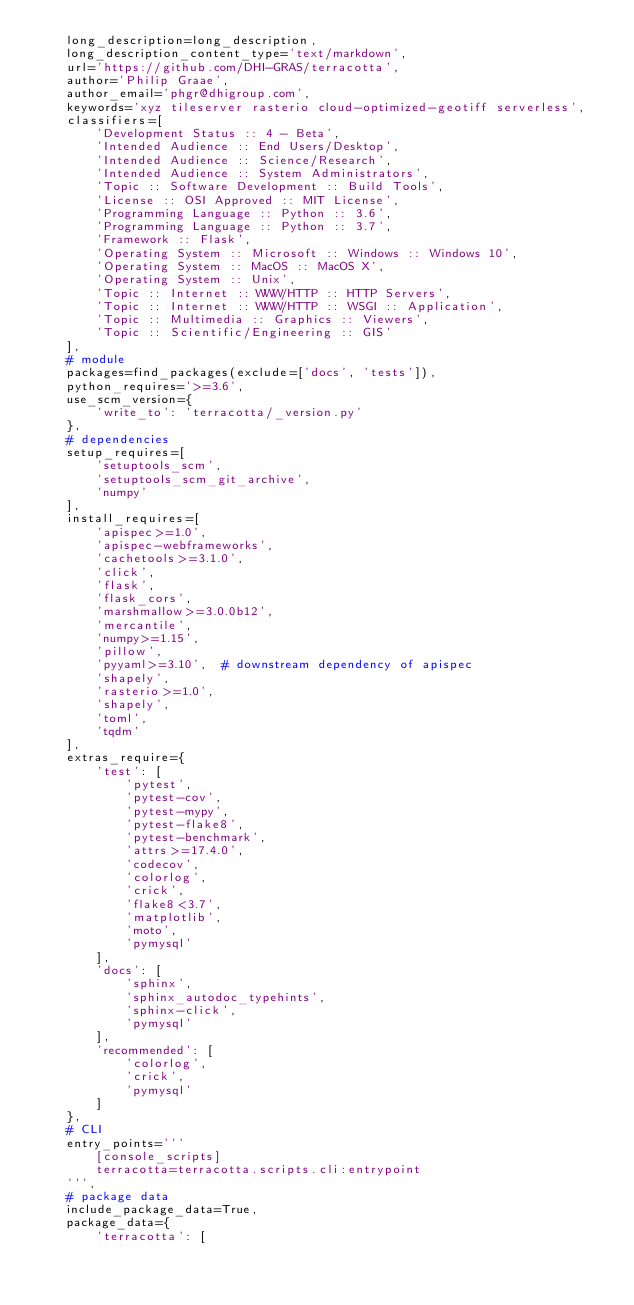<code> <loc_0><loc_0><loc_500><loc_500><_Python_>    long_description=long_description,
    long_description_content_type='text/markdown',
    url='https://github.com/DHI-GRAS/terracotta',
    author='Philip Graae',
    author_email='phgr@dhigroup.com',
    keywords='xyz tileserver rasterio cloud-optimized-geotiff serverless',
    classifiers=[
        'Development Status :: 4 - Beta',
        'Intended Audience :: End Users/Desktop',
        'Intended Audience :: Science/Research',
        'Intended Audience :: System Administrators',
        'Topic :: Software Development :: Build Tools',
        'License :: OSI Approved :: MIT License',
        'Programming Language :: Python :: 3.6',
        'Programming Language :: Python :: 3.7',
        'Framework :: Flask',
        'Operating System :: Microsoft :: Windows :: Windows 10',
        'Operating System :: MacOS :: MacOS X',
        'Operating System :: Unix',
        'Topic :: Internet :: WWW/HTTP :: HTTP Servers',
        'Topic :: Internet :: WWW/HTTP :: WSGI :: Application',
        'Topic :: Multimedia :: Graphics :: Viewers',
        'Topic :: Scientific/Engineering :: GIS'
    ],
    # module
    packages=find_packages(exclude=['docs', 'tests']),
    python_requires='>=3.6',
    use_scm_version={
        'write_to': 'terracotta/_version.py'
    },
    # dependencies
    setup_requires=[
        'setuptools_scm',
        'setuptools_scm_git_archive',
        'numpy'
    ],
    install_requires=[
        'apispec>=1.0',
        'apispec-webframeworks',
        'cachetools>=3.1.0',
        'click',
        'flask',
        'flask_cors',
        'marshmallow>=3.0.0b12',
        'mercantile',
        'numpy>=1.15',
        'pillow',
        'pyyaml>=3.10',  # downstream dependency of apispec
        'shapely',
        'rasterio>=1.0',
        'shapely',
        'toml',
        'tqdm'
    ],
    extras_require={
        'test': [
            'pytest',
            'pytest-cov',
            'pytest-mypy',
            'pytest-flake8',
            'pytest-benchmark',
            'attrs>=17.4.0',
            'codecov',
            'colorlog',
            'crick',
            'flake8<3.7',
            'matplotlib',
            'moto',
            'pymysql'
        ],
        'docs': [
            'sphinx',
            'sphinx_autodoc_typehints',
            'sphinx-click',
            'pymysql'
        ],
        'recommended': [
            'colorlog',
            'crick',
            'pymysql'
        ]
    },
    # CLI
    entry_points='''
        [console_scripts]
        terracotta=terracotta.scripts.cli:entrypoint
    ''',
    # package data
    include_package_data=True,
    package_data={
        'terracotta': [</code> 